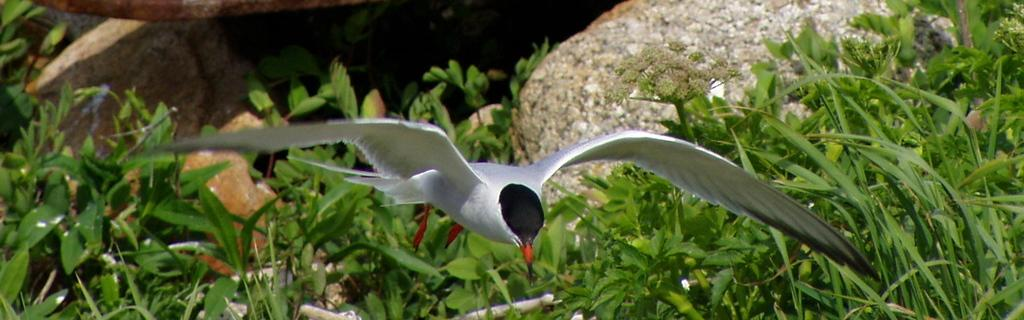What type of plants can be seen in the image? There are green color plants in the image. What other objects are present in the image besides plants? There are rocks in the image. Can you describe the bird in the image? A bird is flying in the air, and it is in white and black color. What type of soda is the bird drinking in the image? There is no soda present in the image; the bird is flying in the air. Can you see any strings attached to the bird in the image? There are no strings attached to the bird in the image; it is flying freely. 